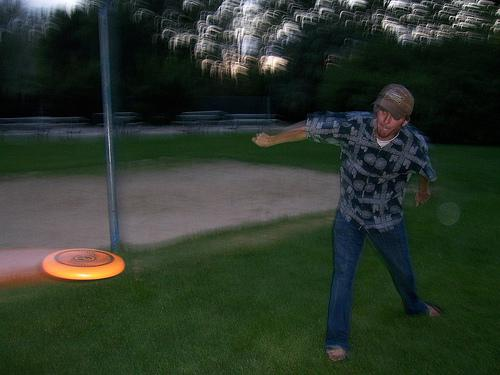Question: what color is the grass?
Choices:
A. Yellow.
B. Green.
C. Light green.
D. Dark green.
Answer with the letter. Answer: B Question: who is in the photo?
Choices:
A. A woman.
B. A girl.
C. A boy.
D. A man.
Answer with the letter. Answer: D Question: when was this picture taken?
Choices:
A. At night.
B. In the morning.
C. Noon.
D. In the evening.
Answer with the letter. Answer: D Question: how many animals are in the photo?
Choices:
A. Zero.
B. Two.
C. One.
D. Three.
Answer with the letter. Answer: A Question: what color is the frisbee?
Choices:
A. Red.
B. Yellow.
C. Orange.
D. Green.
Answer with the letter. Answer: C Question: what does the man have on his head?
Choices:
A. A wig.
B. A hat.
C. Glasses.
D. A comb.
Answer with the letter. Answer: B Question: where was the picture taken?
Choices:
A. On deck.
B. On patio.
C. At a park.
D. At BBQ.
Answer with the letter. Answer: C 